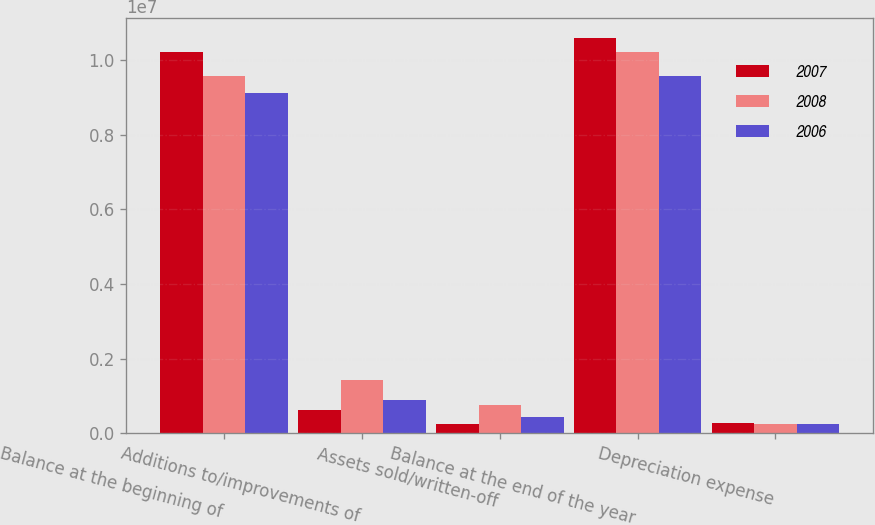<chart> <loc_0><loc_0><loc_500><loc_500><stacked_bar_chart><ecel><fcel>Balance at the beginning of<fcel>Additions to/improvements of<fcel>Assets sold/written-off<fcel>Balance at the end of the year<fcel>Depreciation expense<nl><fcel>2007<fcel>1.02294e+07<fcel>616230<fcel>250236<fcel>1.05954e+07<fcel>258789<nl><fcel>2008<fcel>9.5685e+06<fcel>1.42668e+06<fcel>765757<fcel>1.02294e+07<fcel>245077<nl><fcel>2006<fcel>9.12681e+06<fcel>877860<fcel>436177<fcel>9.5685e+06<fcel>236883<nl></chart> 